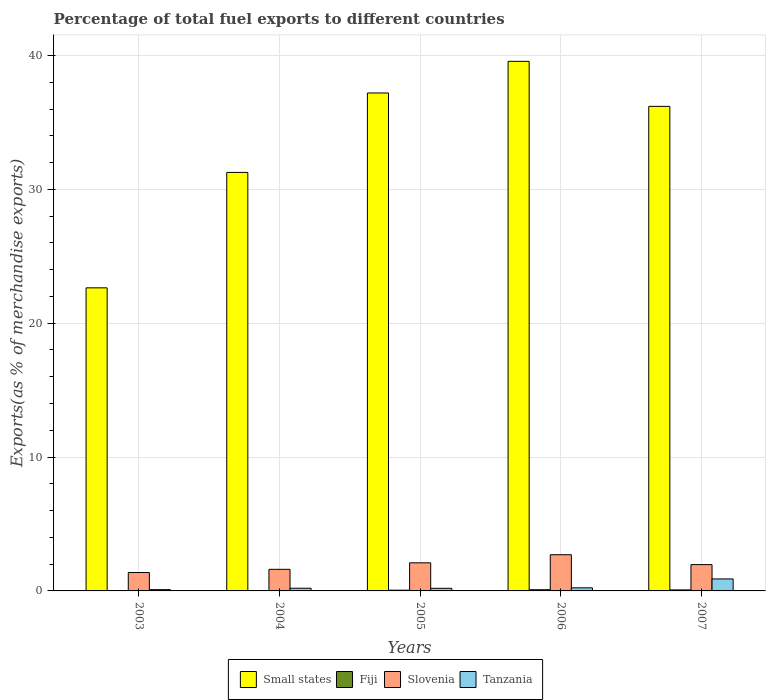How many different coloured bars are there?
Keep it short and to the point. 4. How many groups of bars are there?
Provide a succinct answer. 5. Are the number of bars on each tick of the X-axis equal?
Make the answer very short. Yes. How many bars are there on the 2nd tick from the left?
Offer a very short reply. 4. How many bars are there on the 5th tick from the right?
Keep it short and to the point. 4. In how many cases, is the number of bars for a given year not equal to the number of legend labels?
Offer a terse response. 0. What is the percentage of exports to different countries in Small states in 2007?
Your response must be concise. 36.2. Across all years, what is the maximum percentage of exports to different countries in Fiji?
Give a very brief answer. 0.09. Across all years, what is the minimum percentage of exports to different countries in Tanzania?
Keep it short and to the point. 0.1. In which year was the percentage of exports to different countries in Fiji maximum?
Give a very brief answer. 2006. In which year was the percentage of exports to different countries in Small states minimum?
Your answer should be compact. 2003. What is the total percentage of exports to different countries in Slovenia in the graph?
Keep it short and to the point. 9.76. What is the difference between the percentage of exports to different countries in Fiji in 2005 and that in 2006?
Keep it short and to the point. -0.03. What is the difference between the percentage of exports to different countries in Small states in 2006 and the percentage of exports to different countries in Tanzania in 2004?
Ensure brevity in your answer.  39.36. What is the average percentage of exports to different countries in Small states per year?
Your answer should be very brief. 33.38. In the year 2007, what is the difference between the percentage of exports to different countries in Small states and percentage of exports to different countries in Fiji?
Ensure brevity in your answer.  36.13. What is the ratio of the percentage of exports to different countries in Fiji in 2005 to that in 2006?
Your answer should be very brief. 0.63. Is the percentage of exports to different countries in Fiji in 2004 less than that in 2006?
Provide a succinct answer. Yes. Is the difference between the percentage of exports to different countries in Small states in 2003 and 2007 greater than the difference between the percentage of exports to different countries in Fiji in 2003 and 2007?
Keep it short and to the point. No. What is the difference between the highest and the second highest percentage of exports to different countries in Tanzania?
Your answer should be compact. 0.66. What is the difference between the highest and the lowest percentage of exports to different countries in Slovenia?
Your response must be concise. 1.33. Is it the case that in every year, the sum of the percentage of exports to different countries in Small states and percentage of exports to different countries in Fiji is greater than the sum of percentage of exports to different countries in Tanzania and percentage of exports to different countries in Slovenia?
Your answer should be compact. Yes. What does the 1st bar from the left in 2006 represents?
Your answer should be compact. Small states. What does the 1st bar from the right in 2007 represents?
Give a very brief answer. Tanzania. Are all the bars in the graph horizontal?
Ensure brevity in your answer.  No. What is the difference between two consecutive major ticks on the Y-axis?
Make the answer very short. 10. Does the graph contain any zero values?
Provide a succinct answer. No. Does the graph contain grids?
Provide a succinct answer. Yes. How many legend labels are there?
Keep it short and to the point. 4. How are the legend labels stacked?
Offer a terse response. Horizontal. What is the title of the graph?
Provide a succinct answer. Percentage of total fuel exports to different countries. What is the label or title of the Y-axis?
Ensure brevity in your answer.  Exports(as % of merchandise exports). What is the Exports(as % of merchandise exports) in Small states in 2003?
Your answer should be compact. 22.64. What is the Exports(as % of merchandise exports) of Fiji in 2003?
Offer a terse response. 0. What is the Exports(as % of merchandise exports) in Slovenia in 2003?
Make the answer very short. 1.37. What is the Exports(as % of merchandise exports) in Tanzania in 2003?
Make the answer very short. 0.1. What is the Exports(as % of merchandise exports) of Small states in 2004?
Offer a terse response. 31.27. What is the Exports(as % of merchandise exports) in Fiji in 2004?
Provide a succinct answer. 0.01. What is the Exports(as % of merchandise exports) of Slovenia in 2004?
Make the answer very short. 1.61. What is the Exports(as % of merchandise exports) of Tanzania in 2004?
Offer a terse response. 0.2. What is the Exports(as % of merchandise exports) in Small states in 2005?
Keep it short and to the point. 37.2. What is the Exports(as % of merchandise exports) of Fiji in 2005?
Give a very brief answer. 0.06. What is the Exports(as % of merchandise exports) in Slovenia in 2005?
Make the answer very short. 2.1. What is the Exports(as % of merchandise exports) in Tanzania in 2005?
Offer a very short reply. 0.2. What is the Exports(as % of merchandise exports) in Small states in 2006?
Ensure brevity in your answer.  39.56. What is the Exports(as % of merchandise exports) of Fiji in 2006?
Provide a succinct answer. 0.09. What is the Exports(as % of merchandise exports) of Slovenia in 2006?
Ensure brevity in your answer.  2.7. What is the Exports(as % of merchandise exports) in Tanzania in 2006?
Provide a short and direct response. 0.23. What is the Exports(as % of merchandise exports) in Small states in 2007?
Give a very brief answer. 36.2. What is the Exports(as % of merchandise exports) of Fiji in 2007?
Your response must be concise. 0.08. What is the Exports(as % of merchandise exports) in Slovenia in 2007?
Provide a succinct answer. 1.97. What is the Exports(as % of merchandise exports) of Tanzania in 2007?
Your response must be concise. 0.9. Across all years, what is the maximum Exports(as % of merchandise exports) of Small states?
Offer a terse response. 39.56. Across all years, what is the maximum Exports(as % of merchandise exports) of Fiji?
Your answer should be compact. 0.09. Across all years, what is the maximum Exports(as % of merchandise exports) in Slovenia?
Offer a terse response. 2.7. Across all years, what is the maximum Exports(as % of merchandise exports) in Tanzania?
Your answer should be compact. 0.9. Across all years, what is the minimum Exports(as % of merchandise exports) in Small states?
Offer a very short reply. 22.64. Across all years, what is the minimum Exports(as % of merchandise exports) in Fiji?
Offer a very short reply. 0. Across all years, what is the minimum Exports(as % of merchandise exports) of Slovenia?
Ensure brevity in your answer.  1.37. Across all years, what is the minimum Exports(as % of merchandise exports) in Tanzania?
Make the answer very short. 0.1. What is the total Exports(as % of merchandise exports) of Small states in the graph?
Give a very brief answer. 166.88. What is the total Exports(as % of merchandise exports) in Fiji in the graph?
Keep it short and to the point. 0.23. What is the total Exports(as % of merchandise exports) of Slovenia in the graph?
Your answer should be very brief. 9.76. What is the total Exports(as % of merchandise exports) of Tanzania in the graph?
Your answer should be very brief. 1.62. What is the difference between the Exports(as % of merchandise exports) in Small states in 2003 and that in 2004?
Your answer should be compact. -8.62. What is the difference between the Exports(as % of merchandise exports) of Fiji in 2003 and that in 2004?
Provide a short and direct response. -0.01. What is the difference between the Exports(as % of merchandise exports) of Slovenia in 2003 and that in 2004?
Your answer should be compact. -0.24. What is the difference between the Exports(as % of merchandise exports) in Tanzania in 2003 and that in 2004?
Provide a short and direct response. -0.11. What is the difference between the Exports(as % of merchandise exports) of Small states in 2003 and that in 2005?
Make the answer very short. -14.56. What is the difference between the Exports(as % of merchandise exports) in Fiji in 2003 and that in 2005?
Your answer should be very brief. -0.06. What is the difference between the Exports(as % of merchandise exports) of Slovenia in 2003 and that in 2005?
Ensure brevity in your answer.  -0.72. What is the difference between the Exports(as % of merchandise exports) in Tanzania in 2003 and that in 2005?
Your answer should be compact. -0.1. What is the difference between the Exports(as % of merchandise exports) in Small states in 2003 and that in 2006?
Your response must be concise. -16.92. What is the difference between the Exports(as % of merchandise exports) in Fiji in 2003 and that in 2006?
Provide a succinct answer. -0.09. What is the difference between the Exports(as % of merchandise exports) of Slovenia in 2003 and that in 2006?
Your answer should be very brief. -1.33. What is the difference between the Exports(as % of merchandise exports) of Tanzania in 2003 and that in 2006?
Your response must be concise. -0.14. What is the difference between the Exports(as % of merchandise exports) in Small states in 2003 and that in 2007?
Give a very brief answer. -13.56. What is the difference between the Exports(as % of merchandise exports) in Fiji in 2003 and that in 2007?
Ensure brevity in your answer.  -0.07. What is the difference between the Exports(as % of merchandise exports) of Slovenia in 2003 and that in 2007?
Offer a terse response. -0.59. What is the difference between the Exports(as % of merchandise exports) in Tanzania in 2003 and that in 2007?
Your response must be concise. -0.8. What is the difference between the Exports(as % of merchandise exports) of Small states in 2004 and that in 2005?
Provide a succinct answer. -5.93. What is the difference between the Exports(as % of merchandise exports) of Fiji in 2004 and that in 2005?
Keep it short and to the point. -0.05. What is the difference between the Exports(as % of merchandise exports) of Slovenia in 2004 and that in 2005?
Offer a very short reply. -0.48. What is the difference between the Exports(as % of merchandise exports) of Tanzania in 2004 and that in 2005?
Provide a short and direct response. 0.01. What is the difference between the Exports(as % of merchandise exports) of Small states in 2004 and that in 2006?
Offer a terse response. -8.3. What is the difference between the Exports(as % of merchandise exports) of Fiji in 2004 and that in 2006?
Keep it short and to the point. -0.08. What is the difference between the Exports(as % of merchandise exports) of Slovenia in 2004 and that in 2006?
Keep it short and to the point. -1.09. What is the difference between the Exports(as % of merchandise exports) of Tanzania in 2004 and that in 2006?
Give a very brief answer. -0.03. What is the difference between the Exports(as % of merchandise exports) of Small states in 2004 and that in 2007?
Keep it short and to the point. -4.93. What is the difference between the Exports(as % of merchandise exports) of Fiji in 2004 and that in 2007?
Your response must be concise. -0.07. What is the difference between the Exports(as % of merchandise exports) in Slovenia in 2004 and that in 2007?
Provide a short and direct response. -0.35. What is the difference between the Exports(as % of merchandise exports) in Tanzania in 2004 and that in 2007?
Your answer should be compact. -0.69. What is the difference between the Exports(as % of merchandise exports) of Small states in 2005 and that in 2006?
Ensure brevity in your answer.  -2.36. What is the difference between the Exports(as % of merchandise exports) in Fiji in 2005 and that in 2006?
Your answer should be very brief. -0.03. What is the difference between the Exports(as % of merchandise exports) of Slovenia in 2005 and that in 2006?
Your response must be concise. -0.6. What is the difference between the Exports(as % of merchandise exports) of Tanzania in 2005 and that in 2006?
Provide a succinct answer. -0.04. What is the difference between the Exports(as % of merchandise exports) of Fiji in 2005 and that in 2007?
Keep it short and to the point. -0.02. What is the difference between the Exports(as % of merchandise exports) in Slovenia in 2005 and that in 2007?
Your response must be concise. 0.13. What is the difference between the Exports(as % of merchandise exports) in Tanzania in 2005 and that in 2007?
Ensure brevity in your answer.  -0.7. What is the difference between the Exports(as % of merchandise exports) of Small states in 2006 and that in 2007?
Provide a short and direct response. 3.36. What is the difference between the Exports(as % of merchandise exports) in Fiji in 2006 and that in 2007?
Ensure brevity in your answer.  0.01. What is the difference between the Exports(as % of merchandise exports) in Slovenia in 2006 and that in 2007?
Offer a terse response. 0.74. What is the difference between the Exports(as % of merchandise exports) of Tanzania in 2006 and that in 2007?
Provide a succinct answer. -0.66. What is the difference between the Exports(as % of merchandise exports) of Small states in 2003 and the Exports(as % of merchandise exports) of Fiji in 2004?
Make the answer very short. 22.63. What is the difference between the Exports(as % of merchandise exports) of Small states in 2003 and the Exports(as % of merchandise exports) of Slovenia in 2004?
Ensure brevity in your answer.  21.03. What is the difference between the Exports(as % of merchandise exports) in Small states in 2003 and the Exports(as % of merchandise exports) in Tanzania in 2004?
Offer a terse response. 22.44. What is the difference between the Exports(as % of merchandise exports) of Fiji in 2003 and the Exports(as % of merchandise exports) of Slovenia in 2004?
Provide a succinct answer. -1.61. What is the difference between the Exports(as % of merchandise exports) of Fiji in 2003 and the Exports(as % of merchandise exports) of Tanzania in 2004?
Give a very brief answer. -0.2. What is the difference between the Exports(as % of merchandise exports) in Slovenia in 2003 and the Exports(as % of merchandise exports) in Tanzania in 2004?
Offer a very short reply. 1.17. What is the difference between the Exports(as % of merchandise exports) of Small states in 2003 and the Exports(as % of merchandise exports) of Fiji in 2005?
Provide a succinct answer. 22.59. What is the difference between the Exports(as % of merchandise exports) in Small states in 2003 and the Exports(as % of merchandise exports) in Slovenia in 2005?
Provide a short and direct response. 20.54. What is the difference between the Exports(as % of merchandise exports) of Small states in 2003 and the Exports(as % of merchandise exports) of Tanzania in 2005?
Make the answer very short. 22.45. What is the difference between the Exports(as % of merchandise exports) in Fiji in 2003 and the Exports(as % of merchandise exports) in Slovenia in 2005?
Provide a short and direct response. -2.1. What is the difference between the Exports(as % of merchandise exports) in Fiji in 2003 and the Exports(as % of merchandise exports) in Tanzania in 2005?
Make the answer very short. -0.2. What is the difference between the Exports(as % of merchandise exports) in Slovenia in 2003 and the Exports(as % of merchandise exports) in Tanzania in 2005?
Provide a short and direct response. 1.18. What is the difference between the Exports(as % of merchandise exports) of Small states in 2003 and the Exports(as % of merchandise exports) of Fiji in 2006?
Ensure brevity in your answer.  22.55. What is the difference between the Exports(as % of merchandise exports) in Small states in 2003 and the Exports(as % of merchandise exports) in Slovenia in 2006?
Give a very brief answer. 19.94. What is the difference between the Exports(as % of merchandise exports) in Small states in 2003 and the Exports(as % of merchandise exports) in Tanzania in 2006?
Provide a short and direct response. 22.41. What is the difference between the Exports(as % of merchandise exports) in Fiji in 2003 and the Exports(as % of merchandise exports) in Slovenia in 2006?
Keep it short and to the point. -2.7. What is the difference between the Exports(as % of merchandise exports) of Fiji in 2003 and the Exports(as % of merchandise exports) of Tanzania in 2006?
Make the answer very short. -0.23. What is the difference between the Exports(as % of merchandise exports) of Slovenia in 2003 and the Exports(as % of merchandise exports) of Tanzania in 2006?
Provide a succinct answer. 1.14. What is the difference between the Exports(as % of merchandise exports) of Small states in 2003 and the Exports(as % of merchandise exports) of Fiji in 2007?
Ensure brevity in your answer.  22.57. What is the difference between the Exports(as % of merchandise exports) of Small states in 2003 and the Exports(as % of merchandise exports) of Slovenia in 2007?
Your answer should be very brief. 20.68. What is the difference between the Exports(as % of merchandise exports) of Small states in 2003 and the Exports(as % of merchandise exports) of Tanzania in 2007?
Make the answer very short. 21.75. What is the difference between the Exports(as % of merchandise exports) in Fiji in 2003 and the Exports(as % of merchandise exports) in Slovenia in 2007?
Your answer should be compact. -1.96. What is the difference between the Exports(as % of merchandise exports) in Fiji in 2003 and the Exports(as % of merchandise exports) in Tanzania in 2007?
Ensure brevity in your answer.  -0.9. What is the difference between the Exports(as % of merchandise exports) in Slovenia in 2003 and the Exports(as % of merchandise exports) in Tanzania in 2007?
Make the answer very short. 0.48. What is the difference between the Exports(as % of merchandise exports) of Small states in 2004 and the Exports(as % of merchandise exports) of Fiji in 2005?
Give a very brief answer. 31.21. What is the difference between the Exports(as % of merchandise exports) of Small states in 2004 and the Exports(as % of merchandise exports) of Slovenia in 2005?
Give a very brief answer. 29.17. What is the difference between the Exports(as % of merchandise exports) of Small states in 2004 and the Exports(as % of merchandise exports) of Tanzania in 2005?
Give a very brief answer. 31.07. What is the difference between the Exports(as % of merchandise exports) of Fiji in 2004 and the Exports(as % of merchandise exports) of Slovenia in 2005?
Make the answer very short. -2.09. What is the difference between the Exports(as % of merchandise exports) of Fiji in 2004 and the Exports(as % of merchandise exports) of Tanzania in 2005?
Provide a short and direct response. -0.19. What is the difference between the Exports(as % of merchandise exports) of Slovenia in 2004 and the Exports(as % of merchandise exports) of Tanzania in 2005?
Provide a succinct answer. 1.42. What is the difference between the Exports(as % of merchandise exports) of Small states in 2004 and the Exports(as % of merchandise exports) of Fiji in 2006?
Keep it short and to the point. 31.18. What is the difference between the Exports(as % of merchandise exports) of Small states in 2004 and the Exports(as % of merchandise exports) of Slovenia in 2006?
Ensure brevity in your answer.  28.56. What is the difference between the Exports(as % of merchandise exports) of Small states in 2004 and the Exports(as % of merchandise exports) of Tanzania in 2006?
Your response must be concise. 31.03. What is the difference between the Exports(as % of merchandise exports) in Fiji in 2004 and the Exports(as % of merchandise exports) in Slovenia in 2006?
Keep it short and to the point. -2.7. What is the difference between the Exports(as % of merchandise exports) in Fiji in 2004 and the Exports(as % of merchandise exports) in Tanzania in 2006?
Offer a very short reply. -0.22. What is the difference between the Exports(as % of merchandise exports) in Slovenia in 2004 and the Exports(as % of merchandise exports) in Tanzania in 2006?
Your answer should be compact. 1.38. What is the difference between the Exports(as % of merchandise exports) in Small states in 2004 and the Exports(as % of merchandise exports) in Fiji in 2007?
Provide a short and direct response. 31.19. What is the difference between the Exports(as % of merchandise exports) of Small states in 2004 and the Exports(as % of merchandise exports) of Slovenia in 2007?
Make the answer very short. 29.3. What is the difference between the Exports(as % of merchandise exports) in Small states in 2004 and the Exports(as % of merchandise exports) in Tanzania in 2007?
Give a very brief answer. 30.37. What is the difference between the Exports(as % of merchandise exports) in Fiji in 2004 and the Exports(as % of merchandise exports) in Slovenia in 2007?
Your answer should be very brief. -1.96. What is the difference between the Exports(as % of merchandise exports) in Fiji in 2004 and the Exports(as % of merchandise exports) in Tanzania in 2007?
Offer a terse response. -0.89. What is the difference between the Exports(as % of merchandise exports) in Slovenia in 2004 and the Exports(as % of merchandise exports) in Tanzania in 2007?
Your response must be concise. 0.72. What is the difference between the Exports(as % of merchandise exports) of Small states in 2005 and the Exports(as % of merchandise exports) of Fiji in 2006?
Your answer should be very brief. 37.11. What is the difference between the Exports(as % of merchandise exports) in Small states in 2005 and the Exports(as % of merchandise exports) in Slovenia in 2006?
Ensure brevity in your answer.  34.5. What is the difference between the Exports(as % of merchandise exports) in Small states in 2005 and the Exports(as % of merchandise exports) in Tanzania in 2006?
Your answer should be very brief. 36.97. What is the difference between the Exports(as % of merchandise exports) of Fiji in 2005 and the Exports(as % of merchandise exports) of Slovenia in 2006?
Your response must be concise. -2.65. What is the difference between the Exports(as % of merchandise exports) in Fiji in 2005 and the Exports(as % of merchandise exports) in Tanzania in 2006?
Your answer should be very brief. -0.18. What is the difference between the Exports(as % of merchandise exports) of Slovenia in 2005 and the Exports(as % of merchandise exports) of Tanzania in 2006?
Offer a terse response. 1.87. What is the difference between the Exports(as % of merchandise exports) of Small states in 2005 and the Exports(as % of merchandise exports) of Fiji in 2007?
Give a very brief answer. 37.13. What is the difference between the Exports(as % of merchandise exports) in Small states in 2005 and the Exports(as % of merchandise exports) in Slovenia in 2007?
Your response must be concise. 35.24. What is the difference between the Exports(as % of merchandise exports) of Small states in 2005 and the Exports(as % of merchandise exports) of Tanzania in 2007?
Keep it short and to the point. 36.3. What is the difference between the Exports(as % of merchandise exports) in Fiji in 2005 and the Exports(as % of merchandise exports) in Slovenia in 2007?
Give a very brief answer. -1.91. What is the difference between the Exports(as % of merchandise exports) of Fiji in 2005 and the Exports(as % of merchandise exports) of Tanzania in 2007?
Keep it short and to the point. -0.84. What is the difference between the Exports(as % of merchandise exports) of Slovenia in 2005 and the Exports(as % of merchandise exports) of Tanzania in 2007?
Make the answer very short. 1.2. What is the difference between the Exports(as % of merchandise exports) in Small states in 2006 and the Exports(as % of merchandise exports) in Fiji in 2007?
Ensure brevity in your answer.  39.49. What is the difference between the Exports(as % of merchandise exports) in Small states in 2006 and the Exports(as % of merchandise exports) in Slovenia in 2007?
Ensure brevity in your answer.  37.6. What is the difference between the Exports(as % of merchandise exports) in Small states in 2006 and the Exports(as % of merchandise exports) in Tanzania in 2007?
Provide a succinct answer. 38.67. What is the difference between the Exports(as % of merchandise exports) of Fiji in 2006 and the Exports(as % of merchandise exports) of Slovenia in 2007?
Make the answer very short. -1.88. What is the difference between the Exports(as % of merchandise exports) in Fiji in 2006 and the Exports(as % of merchandise exports) in Tanzania in 2007?
Offer a terse response. -0.81. What is the difference between the Exports(as % of merchandise exports) in Slovenia in 2006 and the Exports(as % of merchandise exports) in Tanzania in 2007?
Your answer should be very brief. 1.81. What is the average Exports(as % of merchandise exports) in Small states per year?
Give a very brief answer. 33.38. What is the average Exports(as % of merchandise exports) of Fiji per year?
Ensure brevity in your answer.  0.05. What is the average Exports(as % of merchandise exports) of Slovenia per year?
Provide a succinct answer. 1.95. What is the average Exports(as % of merchandise exports) in Tanzania per year?
Provide a succinct answer. 0.32. In the year 2003, what is the difference between the Exports(as % of merchandise exports) of Small states and Exports(as % of merchandise exports) of Fiji?
Provide a succinct answer. 22.64. In the year 2003, what is the difference between the Exports(as % of merchandise exports) in Small states and Exports(as % of merchandise exports) in Slovenia?
Your response must be concise. 21.27. In the year 2003, what is the difference between the Exports(as % of merchandise exports) in Small states and Exports(as % of merchandise exports) in Tanzania?
Provide a short and direct response. 22.55. In the year 2003, what is the difference between the Exports(as % of merchandise exports) in Fiji and Exports(as % of merchandise exports) in Slovenia?
Ensure brevity in your answer.  -1.37. In the year 2003, what is the difference between the Exports(as % of merchandise exports) in Fiji and Exports(as % of merchandise exports) in Tanzania?
Offer a very short reply. -0.1. In the year 2003, what is the difference between the Exports(as % of merchandise exports) of Slovenia and Exports(as % of merchandise exports) of Tanzania?
Provide a succinct answer. 1.28. In the year 2004, what is the difference between the Exports(as % of merchandise exports) of Small states and Exports(as % of merchandise exports) of Fiji?
Offer a terse response. 31.26. In the year 2004, what is the difference between the Exports(as % of merchandise exports) of Small states and Exports(as % of merchandise exports) of Slovenia?
Your answer should be compact. 29.65. In the year 2004, what is the difference between the Exports(as % of merchandise exports) in Small states and Exports(as % of merchandise exports) in Tanzania?
Offer a terse response. 31.07. In the year 2004, what is the difference between the Exports(as % of merchandise exports) in Fiji and Exports(as % of merchandise exports) in Slovenia?
Your answer should be very brief. -1.61. In the year 2004, what is the difference between the Exports(as % of merchandise exports) of Fiji and Exports(as % of merchandise exports) of Tanzania?
Offer a terse response. -0.19. In the year 2004, what is the difference between the Exports(as % of merchandise exports) of Slovenia and Exports(as % of merchandise exports) of Tanzania?
Make the answer very short. 1.41. In the year 2005, what is the difference between the Exports(as % of merchandise exports) of Small states and Exports(as % of merchandise exports) of Fiji?
Offer a terse response. 37.15. In the year 2005, what is the difference between the Exports(as % of merchandise exports) in Small states and Exports(as % of merchandise exports) in Slovenia?
Offer a very short reply. 35.1. In the year 2005, what is the difference between the Exports(as % of merchandise exports) in Small states and Exports(as % of merchandise exports) in Tanzania?
Your answer should be compact. 37.01. In the year 2005, what is the difference between the Exports(as % of merchandise exports) of Fiji and Exports(as % of merchandise exports) of Slovenia?
Keep it short and to the point. -2.04. In the year 2005, what is the difference between the Exports(as % of merchandise exports) of Fiji and Exports(as % of merchandise exports) of Tanzania?
Your answer should be compact. -0.14. In the year 2005, what is the difference between the Exports(as % of merchandise exports) in Slovenia and Exports(as % of merchandise exports) in Tanzania?
Your answer should be compact. 1.9. In the year 2006, what is the difference between the Exports(as % of merchandise exports) in Small states and Exports(as % of merchandise exports) in Fiji?
Give a very brief answer. 39.48. In the year 2006, what is the difference between the Exports(as % of merchandise exports) of Small states and Exports(as % of merchandise exports) of Slovenia?
Provide a succinct answer. 36.86. In the year 2006, what is the difference between the Exports(as % of merchandise exports) in Small states and Exports(as % of merchandise exports) in Tanzania?
Offer a very short reply. 39.33. In the year 2006, what is the difference between the Exports(as % of merchandise exports) of Fiji and Exports(as % of merchandise exports) of Slovenia?
Give a very brief answer. -2.62. In the year 2006, what is the difference between the Exports(as % of merchandise exports) in Fiji and Exports(as % of merchandise exports) in Tanzania?
Ensure brevity in your answer.  -0.14. In the year 2006, what is the difference between the Exports(as % of merchandise exports) in Slovenia and Exports(as % of merchandise exports) in Tanzania?
Your answer should be compact. 2.47. In the year 2007, what is the difference between the Exports(as % of merchandise exports) of Small states and Exports(as % of merchandise exports) of Fiji?
Offer a terse response. 36.13. In the year 2007, what is the difference between the Exports(as % of merchandise exports) in Small states and Exports(as % of merchandise exports) in Slovenia?
Make the answer very short. 34.24. In the year 2007, what is the difference between the Exports(as % of merchandise exports) in Small states and Exports(as % of merchandise exports) in Tanzania?
Keep it short and to the point. 35.3. In the year 2007, what is the difference between the Exports(as % of merchandise exports) of Fiji and Exports(as % of merchandise exports) of Slovenia?
Offer a terse response. -1.89. In the year 2007, what is the difference between the Exports(as % of merchandise exports) in Fiji and Exports(as % of merchandise exports) in Tanzania?
Ensure brevity in your answer.  -0.82. In the year 2007, what is the difference between the Exports(as % of merchandise exports) in Slovenia and Exports(as % of merchandise exports) in Tanzania?
Make the answer very short. 1.07. What is the ratio of the Exports(as % of merchandise exports) of Small states in 2003 to that in 2004?
Your answer should be compact. 0.72. What is the ratio of the Exports(as % of merchandise exports) in Fiji in 2003 to that in 2004?
Give a very brief answer. 0.06. What is the ratio of the Exports(as % of merchandise exports) of Slovenia in 2003 to that in 2004?
Provide a succinct answer. 0.85. What is the ratio of the Exports(as % of merchandise exports) of Tanzania in 2003 to that in 2004?
Your answer should be very brief. 0.48. What is the ratio of the Exports(as % of merchandise exports) in Small states in 2003 to that in 2005?
Provide a succinct answer. 0.61. What is the ratio of the Exports(as % of merchandise exports) of Fiji in 2003 to that in 2005?
Make the answer very short. 0.01. What is the ratio of the Exports(as % of merchandise exports) in Slovenia in 2003 to that in 2005?
Your answer should be compact. 0.65. What is the ratio of the Exports(as % of merchandise exports) in Tanzania in 2003 to that in 2005?
Your answer should be very brief. 0.49. What is the ratio of the Exports(as % of merchandise exports) in Small states in 2003 to that in 2006?
Your answer should be very brief. 0.57. What is the ratio of the Exports(as % of merchandise exports) of Fiji in 2003 to that in 2006?
Offer a very short reply. 0.01. What is the ratio of the Exports(as % of merchandise exports) of Slovenia in 2003 to that in 2006?
Your answer should be compact. 0.51. What is the ratio of the Exports(as % of merchandise exports) in Tanzania in 2003 to that in 2006?
Offer a very short reply. 0.41. What is the ratio of the Exports(as % of merchandise exports) of Small states in 2003 to that in 2007?
Give a very brief answer. 0.63. What is the ratio of the Exports(as % of merchandise exports) in Fiji in 2003 to that in 2007?
Your answer should be very brief. 0.01. What is the ratio of the Exports(as % of merchandise exports) in Slovenia in 2003 to that in 2007?
Ensure brevity in your answer.  0.7. What is the ratio of the Exports(as % of merchandise exports) in Tanzania in 2003 to that in 2007?
Your answer should be compact. 0.11. What is the ratio of the Exports(as % of merchandise exports) in Small states in 2004 to that in 2005?
Your answer should be compact. 0.84. What is the ratio of the Exports(as % of merchandise exports) of Fiji in 2004 to that in 2005?
Ensure brevity in your answer.  0.15. What is the ratio of the Exports(as % of merchandise exports) of Slovenia in 2004 to that in 2005?
Ensure brevity in your answer.  0.77. What is the ratio of the Exports(as % of merchandise exports) of Tanzania in 2004 to that in 2005?
Your answer should be compact. 1.03. What is the ratio of the Exports(as % of merchandise exports) in Small states in 2004 to that in 2006?
Provide a short and direct response. 0.79. What is the ratio of the Exports(as % of merchandise exports) of Fiji in 2004 to that in 2006?
Provide a short and direct response. 0.1. What is the ratio of the Exports(as % of merchandise exports) of Slovenia in 2004 to that in 2006?
Your response must be concise. 0.6. What is the ratio of the Exports(as % of merchandise exports) of Tanzania in 2004 to that in 2006?
Keep it short and to the point. 0.87. What is the ratio of the Exports(as % of merchandise exports) of Small states in 2004 to that in 2007?
Offer a very short reply. 0.86. What is the ratio of the Exports(as % of merchandise exports) in Fiji in 2004 to that in 2007?
Your response must be concise. 0.11. What is the ratio of the Exports(as % of merchandise exports) of Slovenia in 2004 to that in 2007?
Your response must be concise. 0.82. What is the ratio of the Exports(as % of merchandise exports) of Tanzania in 2004 to that in 2007?
Make the answer very short. 0.22. What is the ratio of the Exports(as % of merchandise exports) of Small states in 2005 to that in 2006?
Provide a short and direct response. 0.94. What is the ratio of the Exports(as % of merchandise exports) of Fiji in 2005 to that in 2006?
Ensure brevity in your answer.  0.63. What is the ratio of the Exports(as % of merchandise exports) in Slovenia in 2005 to that in 2006?
Offer a very short reply. 0.78. What is the ratio of the Exports(as % of merchandise exports) in Tanzania in 2005 to that in 2006?
Provide a succinct answer. 0.84. What is the ratio of the Exports(as % of merchandise exports) in Small states in 2005 to that in 2007?
Provide a short and direct response. 1.03. What is the ratio of the Exports(as % of merchandise exports) in Fiji in 2005 to that in 2007?
Give a very brief answer. 0.74. What is the ratio of the Exports(as % of merchandise exports) in Slovenia in 2005 to that in 2007?
Ensure brevity in your answer.  1.07. What is the ratio of the Exports(as % of merchandise exports) of Tanzania in 2005 to that in 2007?
Give a very brief answer. 0.22. What is the ratio of the Exports(as % of merchandise exports) in Small states in 2006 to that in 2007?
Your answer should be very brief. 1.09. What is the ratio of the Exports(as % of merchandise exports) of Fiji in 2006 to that in 2007?
Offer a terse response. 1.17. What is the ratio of the Exports(as % of merchandise exports) of Slovenia in 2006 to that in 2007?
Keep it short and to the point. 1.38. What is the ratio of the Exports(as % of merchandise exports) in Tanzania in 2006 to that in 2007?
Keep it short and to the point. 0.26. What is the difference between the highest and the second highest Exports(as % of merchandise exports) in Small states?
Provide a short and direct response. 2.36. What is the difference between the highest and the second highest Exports(as % of merchandise exports) of Fiji?
Provide a succinct answer. 0.01. What is the difference between the highest and the second highest Exports(as % of merchandise exports) of Slovenia?
Your answer should be very brief. 0.6. What is the difference between the highest and the second highest Exports(as % of merchandise exports) in Tanzania?
Make the answer very short. 0.66. What is the difference between the highest and the lowest Exports(as % of merchandise exports) of Small states?
Your response must be concise. 16.92. What is the difference between the highest and the lowest Exports(as % of merchandise exports) in Fiji?
Your answer should be compact. 0.09. What is the difference between the highest and the lowest Exports(as % of merchandise exports) in Slovenia?
Keep it short and to the point. 1.33. What is the difference between the highest and the lowest Exports(as % of merchandise exports) of Tanzania?
Give a very brief answer. 0.8. 